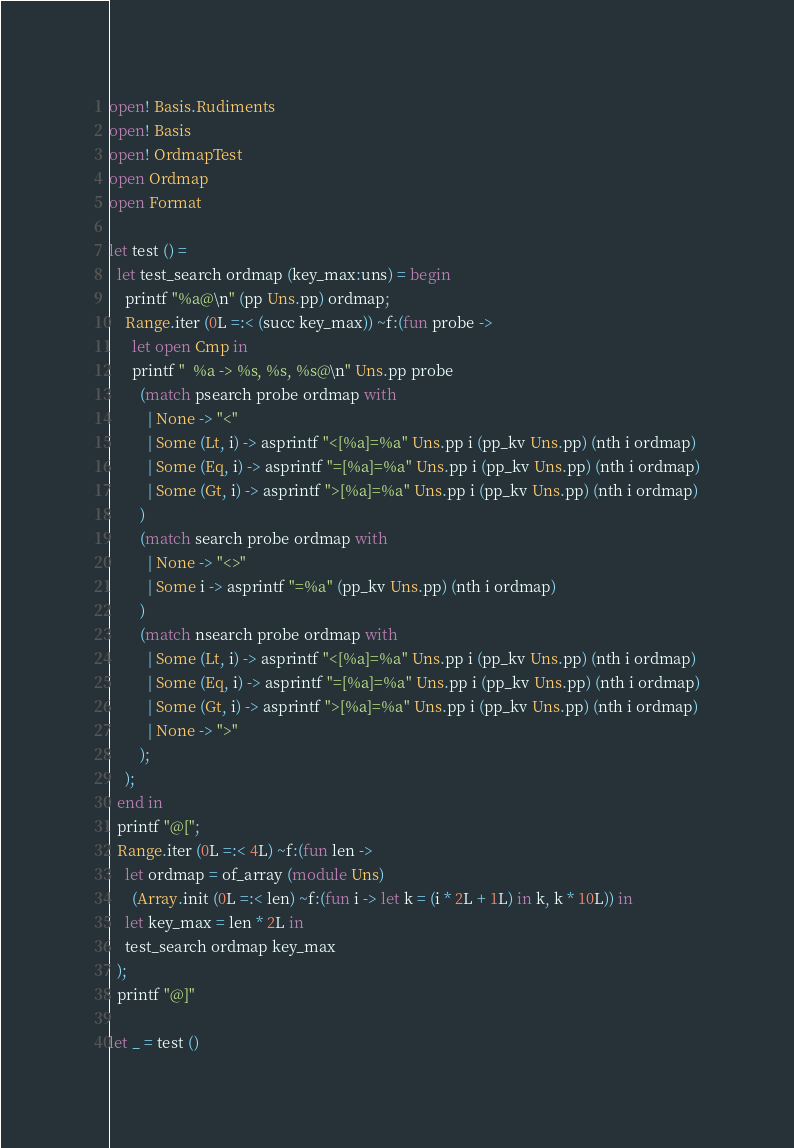Convert code to text. <code><loc_0><loc_0><loc_500><loc_500><_OCaml_>open! Basis.Rudiments
open! Basis
open! OrdmapTest
open Ordmap
open Format

let test () =
  let test_search ordmap (key_max:uns) = begin
    printf "%a@\n" (pp Uns.pp) ordmap;
    Range.iter (0L =:< (succ key_max)) ~f:(fun probe ->
      let open Cmp in
      printf "  %a -> %s, %s, %s@\n" Uns.pp probe
        (match psearch probe ordmap with
          | None -> "<"
          | Some (Lt, i) -> asprintf "<[%a]=%a" Uns.pp i (pp_kv Uns.pp) (nth i ordmap)
          | Some (Eq, i) -> asprintf "=[%a]=%a" Uns.pp i (pp_kv Uns.pp) (nth i ordmap)
          | Some (Gt, i) -> asprintf ">[%a]=%a" Uns.pp i (pp_kv Uns.pp) (nth i ordmap)
        )
        (match search probe ordmap with
          | None -> "<>"
          | Some i -> asprintf "=%a" (pp_kv Uns.pp) (nth i ordmap)
        )
        (match nsearch probe ordmap with
          | Some (Lt, i) -> asprintf "<[%a]=%a" Uns.pp i (pp_kv Uns.pp) (nth i ordmap)
          | Some (Eq, i) -> asprintf "=[%a]=%a" Uns.pp i (pp_kv Uns.pp) (nth i ordmap)
          | Some (Gt, i) -> asprintf ">[%a]=%a" Uns.pp i (pp_kv Uns.pp) (nth i ordmap)
          | None -> ">"
        );
    );
  end in
  printf "@[";
  Range.iter (0L =:< 4L) ~f:(fun len ->
    let ordmap = of_array (module Uns)
      (Array.init (0L =:< len) ~f:(fun i -> let k = (i * 2L + 1L) in k, k * 10L)) in
    let key_max = len * 2L in
    test_search ordmap key_max
  );
  printf "@]"

let _ = test ()
</code> 